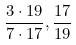<formula> <loc_0><loc_0><loc_500><loc_500>\frac { 3 \cdot 1 9 } { 7 \cdot 1 7 } , \frac { 1 7 } { 1 9 }</formula> 